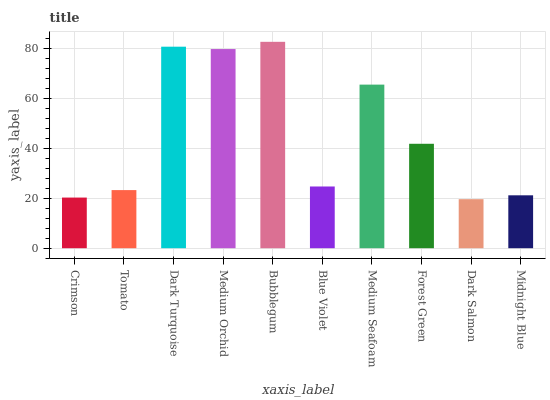Is Dark Salmon the minimum?
Answer yes or no. Yes. Is Bubblegum the maximum?
Answer yes or no. Yes. Is Tomato the minimum?
Answer yes or no. No. Is Tomato the maximum?
Answer yes or no. No. Is Tomato greater than Crimson?
Answer yes or no. Yes. Is Crimson less than Tomato?
Answer yes or no. Yes. Is Crimson greater than Tomato?
Answer yes or no. No. Is Tomato less than Crimson?
Answer yes or no. No. Is Forest Green the high median?
Answer yes or no. Yes. Is Blue Violet the low median?
Answer yes or no. Yes. Is Bubblegum the high median?
Answer yes or no. No. Is Medium Orchid the low median?
Answer yes or no. No. 